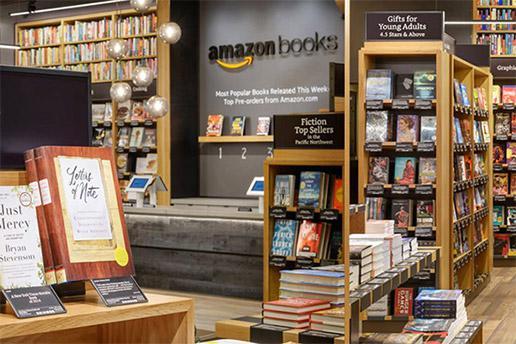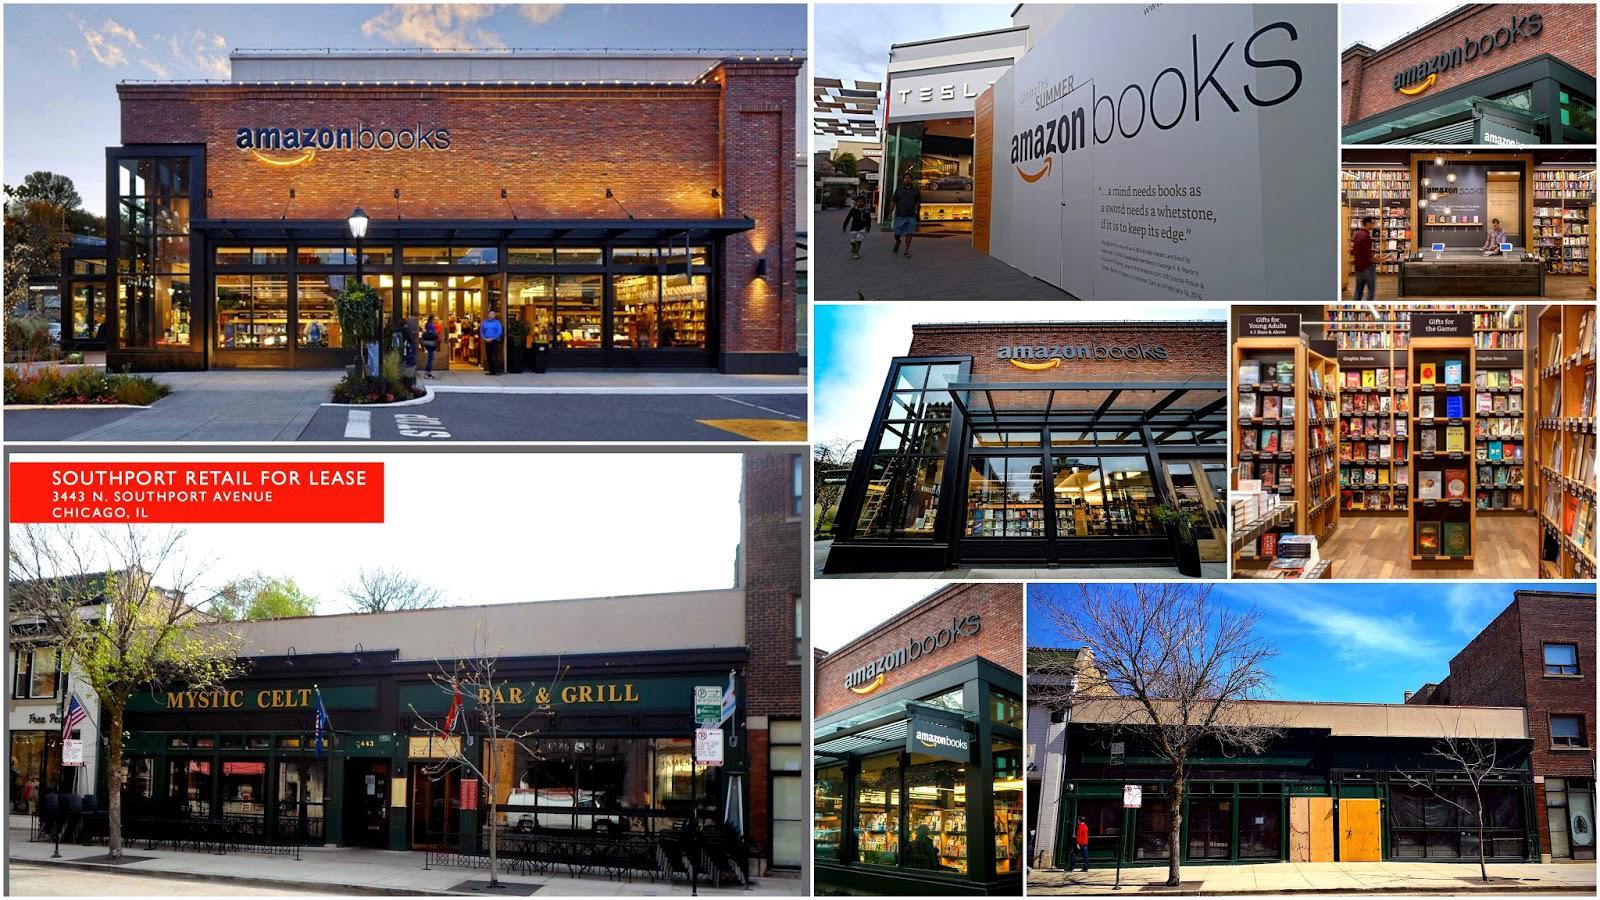The first image is the image on the left, the second image is the image on the right. Analyze the images presented: Is the assertion "There are at least 5 stack of 4 books on the lower part of the display with the bottom of each book facing forward." valid? Answer yes or no. No. The first image is the image on the left, the second image is the image on the right. For the images shown, is this caption "A person wearing black is standing on each side of one image, with a tiered stand of books topped with a horizontal black sign between the people." true? Answer yes or no. No. 